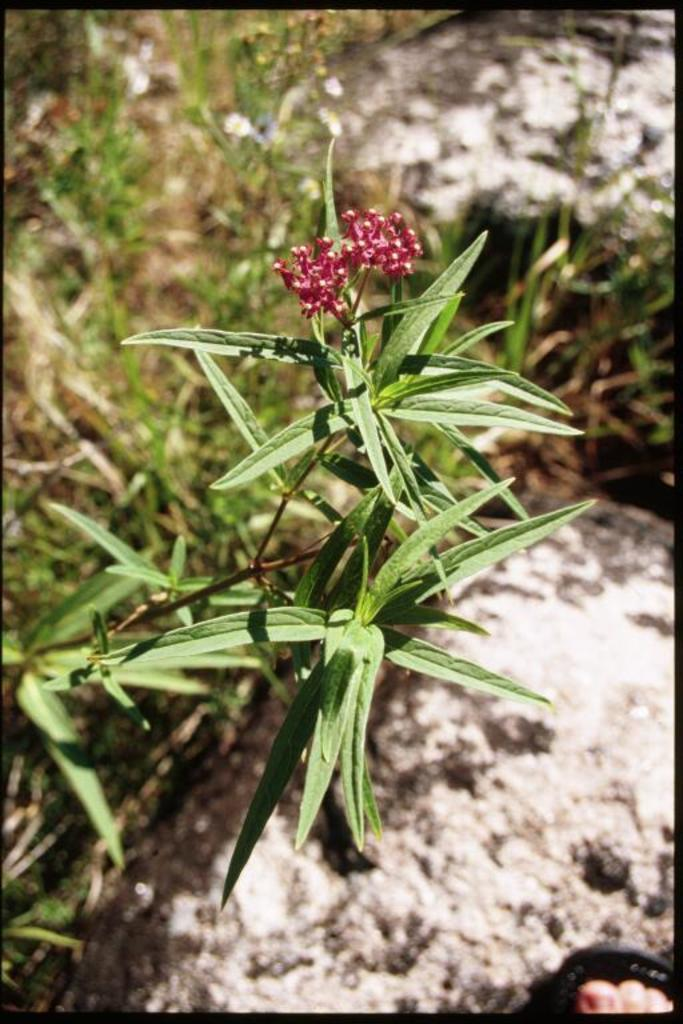What type of flowers can be seen in the image? There are two red color flowers in the image. What is the color of the plants in the image? The plants in the image are green. What can be seen in the background of the image? There are rocks visible in the background of the image. Can you read the receipt that is lying on the ground in the image? There is no receipt present in the image; it only features flowers, plants, and rocks. 